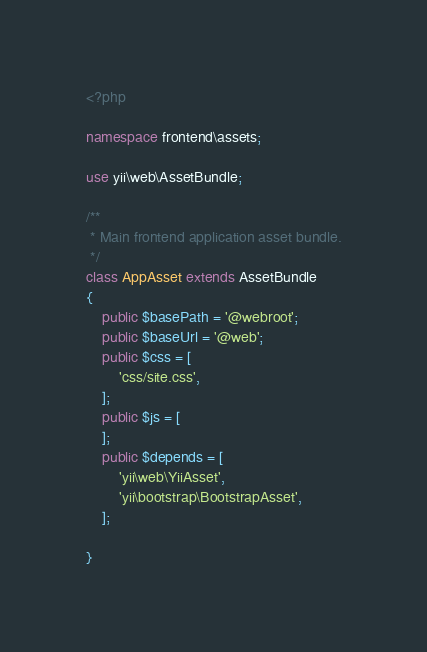Convert code to text. <code><loc_0><loc_0><loc_500><loc_500><_PHP_><?php

namespace frontend\assets;

use yii\web\AssetBundle;

/**
 * Main frontend application asset bundle.
 */
class AppAsset extends AssetBundle
{
    public $basePath = '@webroot';
    public $baseUrl = '@web';
    public $css = [
        'css/site.css',
    ];
    public $js = [
    ];
    public $depends = [
        'yii\web\YiiAsset',
        'yii\bootstrap\BootstrapAsset',
    ];
    
}
</code> 